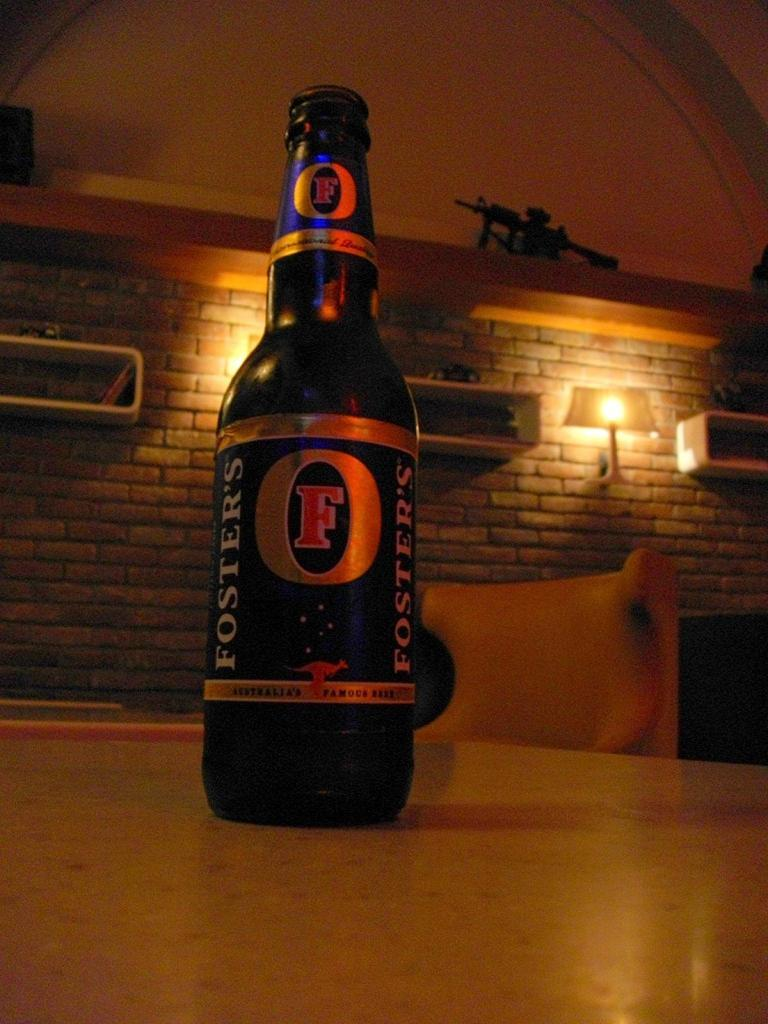<image>
Describe the image concisely. A bottle of Foster's beer sits on a table in a room with dim lighting. 